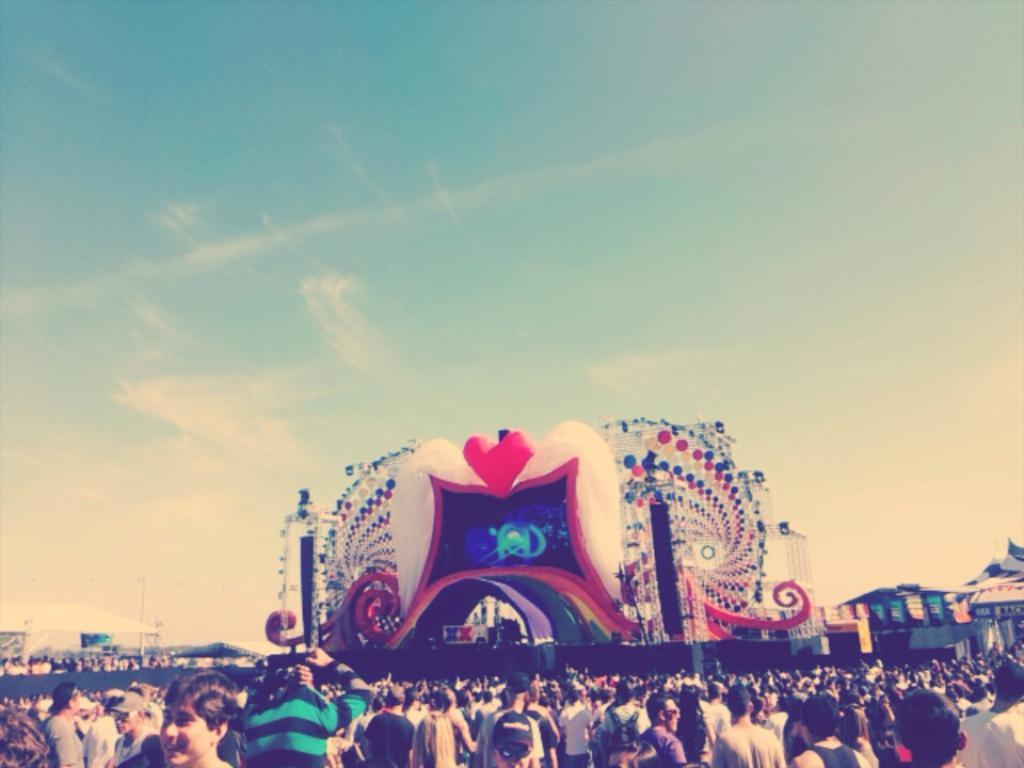What is the main subject in the center of the image? There is architecture in the center of the image. Can you describe the people in the image? There is a group of people standing in the image. What can be seen in the background of the image? The sky, clouds, and tents are present in the background of the image. How many chairs are visible in the image? There are no chairs visible in the image. What type of army is present in the image? There is no army present in the image. 